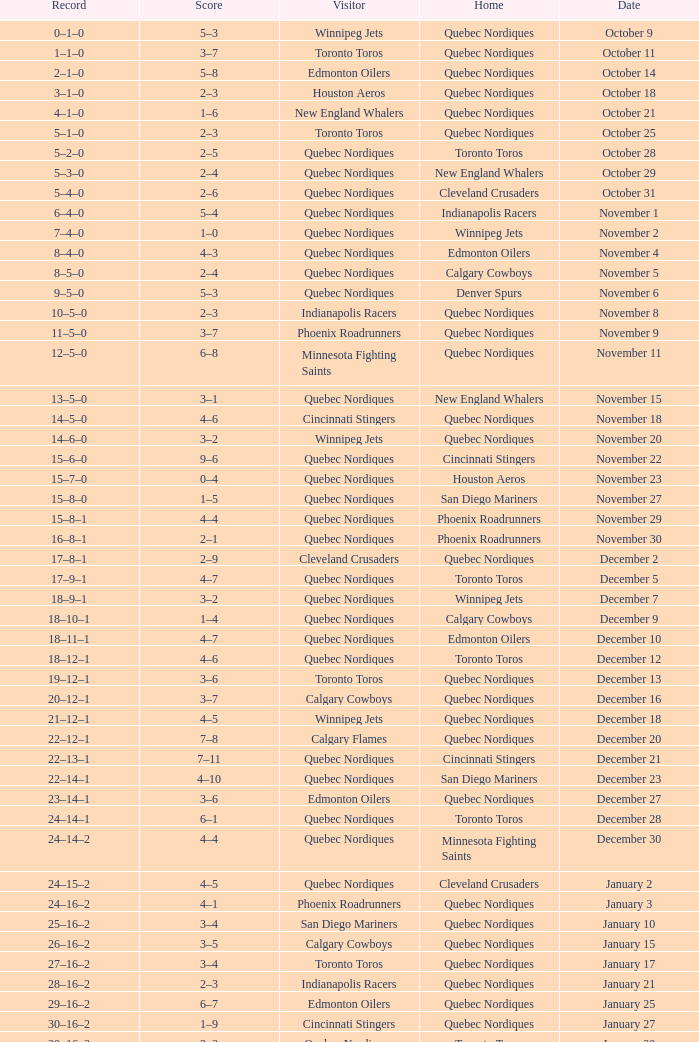What was the score of the game when the record was 39–21–4? 5–4. 